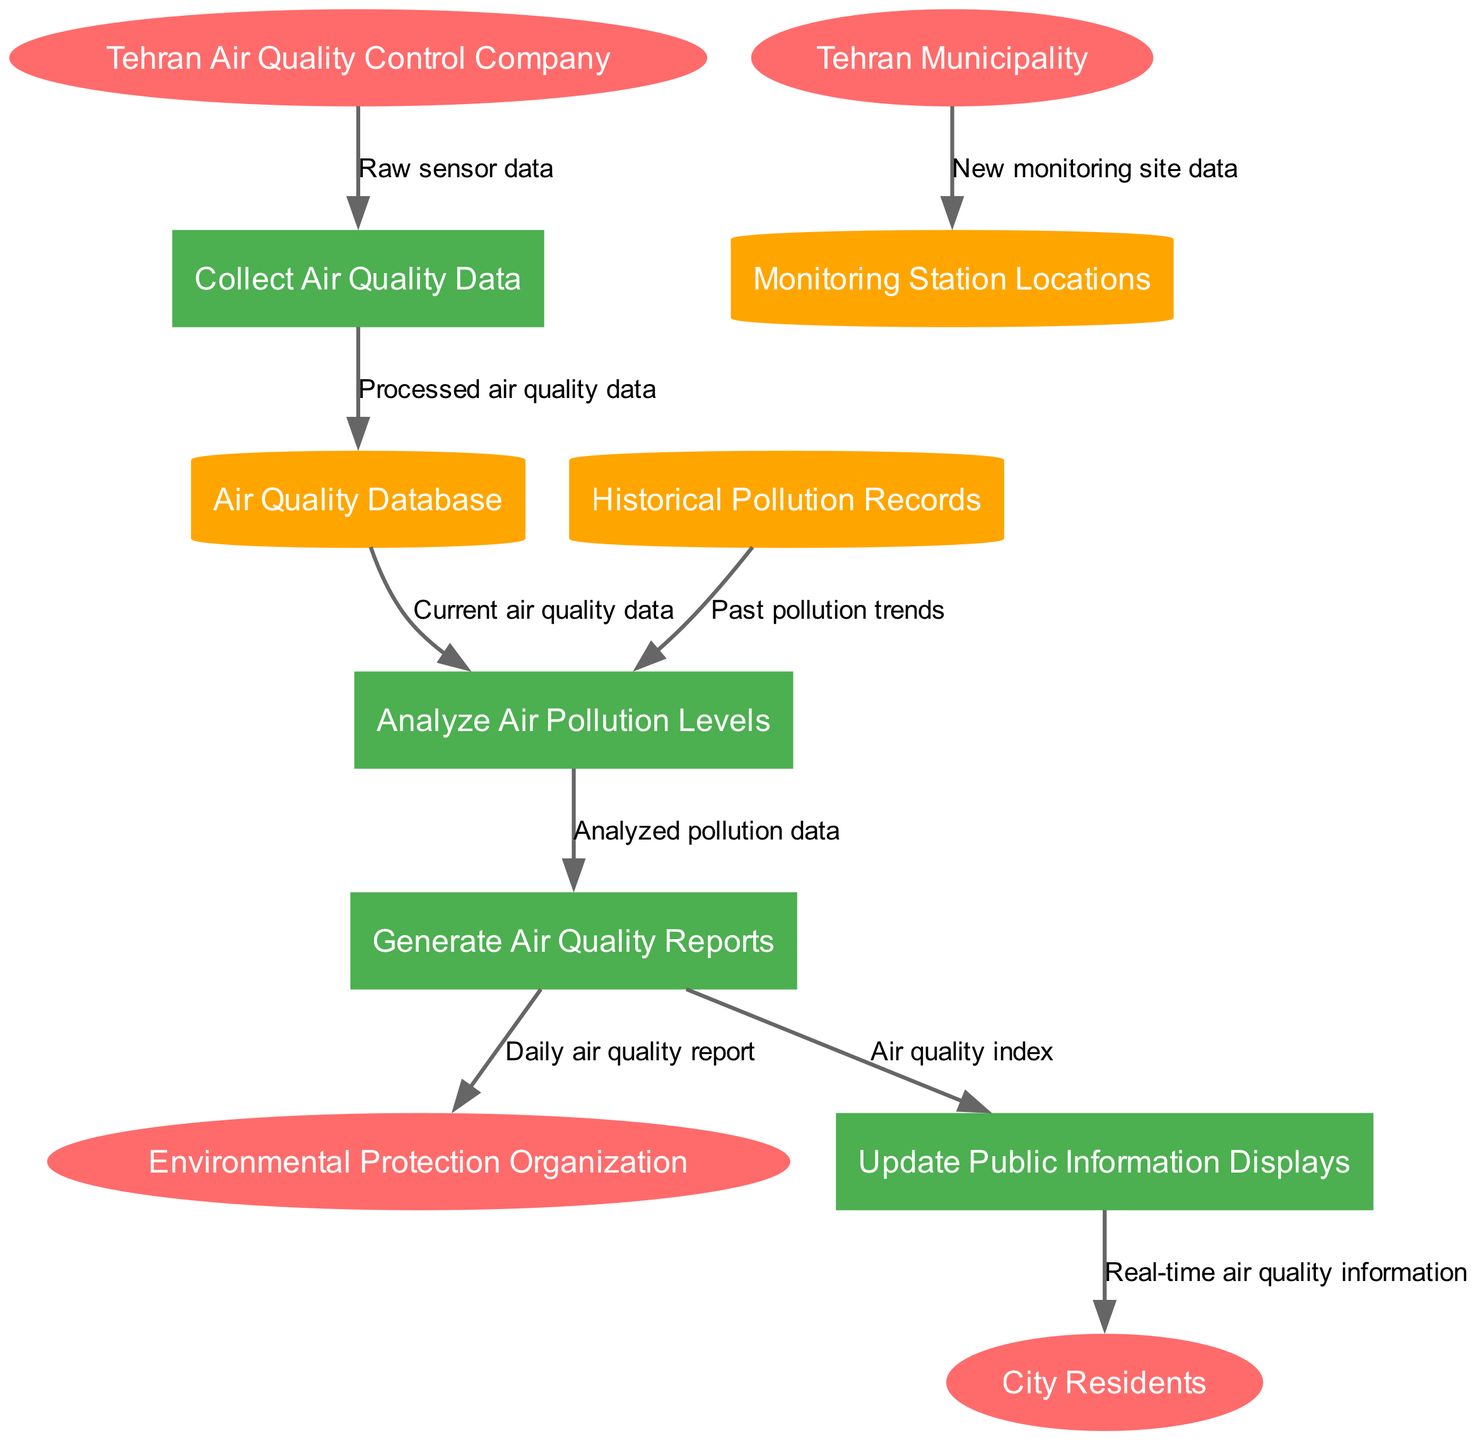What is the total number of external entities in the diagram? The diagram shows four external entities: 'Tehran Air Quality Control Company', 'City Residents', 'Environmental Protection Organization', and 'Tehran Municipality'. Counting these gives a total of four.
Answer: 4 Which entity provides raw sensor data? The data flow indicates that 'Tehran Air Quality Control Company' sends raw sensor data to the process 'Collect Air Quality Data'.
Answer: Tehran Air Quality Control Company How many processes are defined in the diagram? There are four processes: 'Collect Air Quality Data', 'Analyze Air Pollution Levels', 'Generate Air Quality Reports', and 'Update Public Information Displays'. Counting these yields four processes.
Answer: 4 What type of data store is 'Air Quality Database'? The diagram categorizes 'Air Quality Database' as a cylinder shape, which represents a data store in Data Flow Diagrams.
Answer: Data Store Which process generates reports for the Environmental Protection Organization? The process 'Generate Air Quality Reports' outputs the 'Daily air quality report' to the 'Environmental Protection Organization'.
Answer: Generate Air Quality Reports What is the label for the data flow from 'Update Public Information Displays' to 'City Residents'? According to the diagram, the data flow between these two nodes is labeled 'Real-time air quality information'.
Answer: Real-time air quality information What data is provided to 'Analyze Air Pollution Levels' from 'Historical Pollution Records'? The diagram indicates that the 'Historical Pollution Records' provide 'Past pollution trends' to the 'Analyze Air Pollution Levels' process.
Answer: Past pollution trends Which process comes after 'Collect Air Quality Data'? The flow shows that after collecting data, it is stored in the 'Air Quality Database' and then sent to 'Analyze Air Pollution Levels'. Thus, the next process is 'Analyze Air Pollution Levels'.
Answer: Analyze Air Pollution Levels What is the main output of the 'Generate Air Quality Reports'? The primary outputs from 'Generate Air Quality Reports' include two flows: 'Daily air quality report' to the 'Environmental Protection Organization' and 'Air quality index' to 'Update Public Information Displays'. Both are considered significant outputs.
Answer: Daily air quality report and Air quality index 